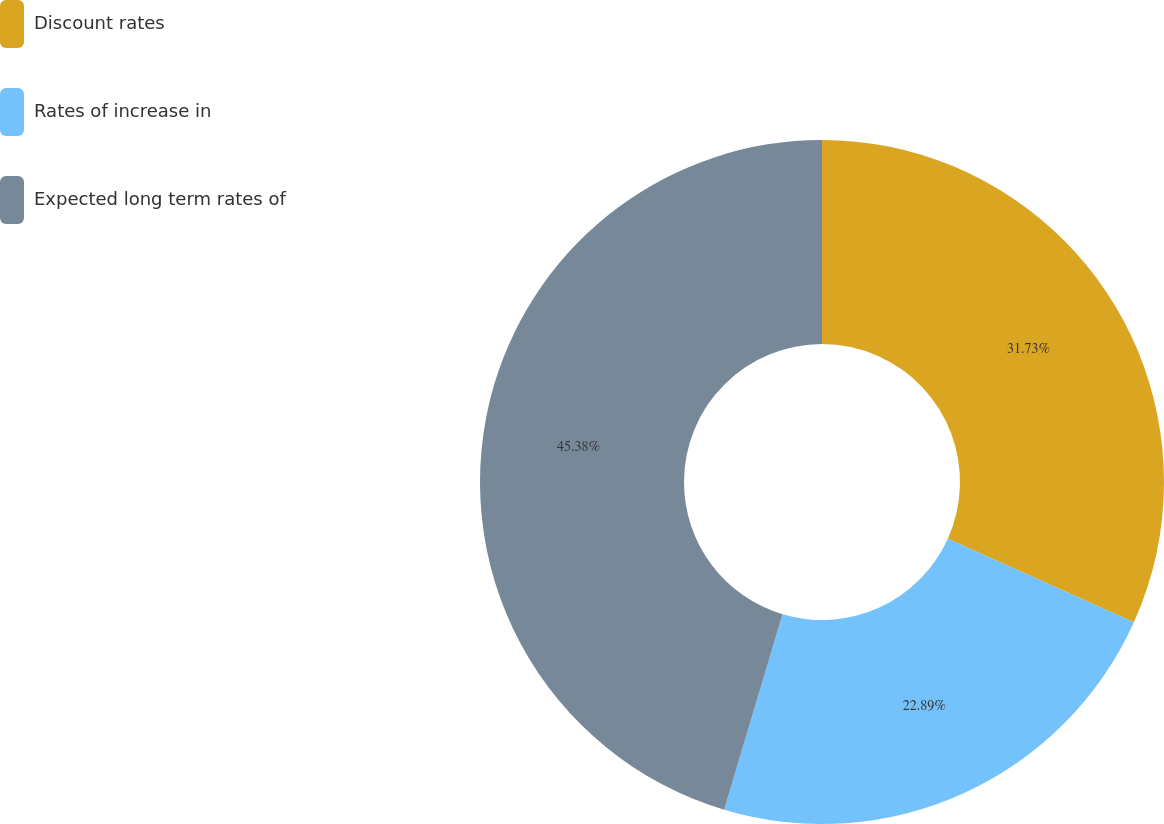<chart> <loc_0><loc_0><loc_500><loc_500><pie_chart><fcel>Discount rates<fcel>Rates of increase in<fcel>Expected long term rates of<nl><fcel>31.73%<fcel>22.89%<fcel>45.38%<nl></chart> 